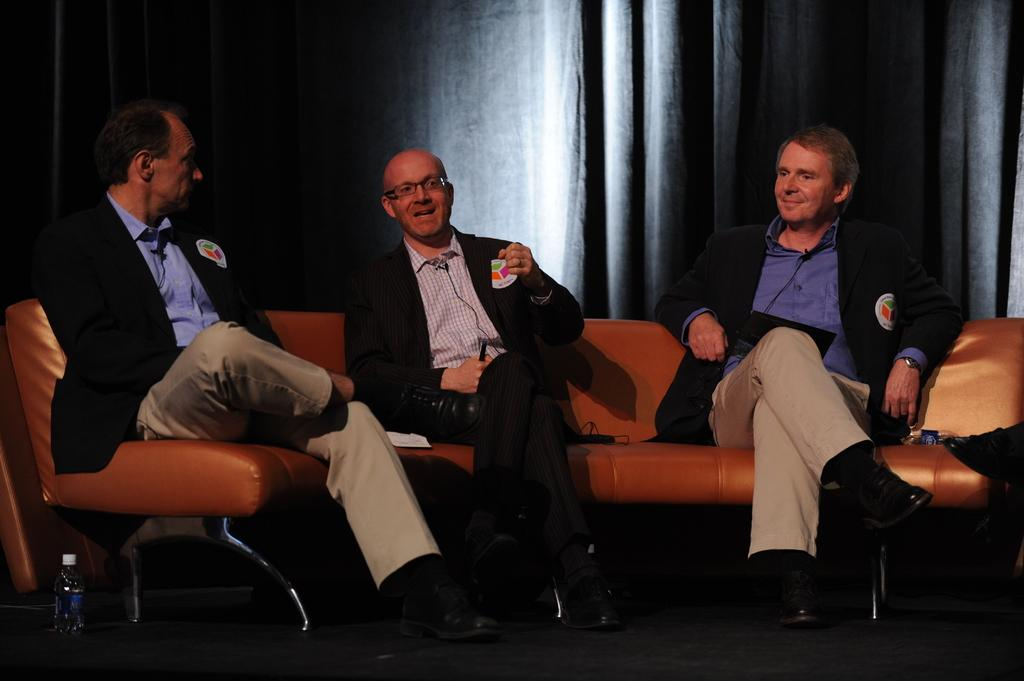How many people are in the image? There are three men in the image. What are the men doing in the image? The men are sitting on a couch. What are the men wearing in the image? The men are wearing suits. What can be seen in the background of the image? There is a black-colored curtain in the background. What object is on the left side of the image? There is a water bottle on the left side of the image. What type of eye is visible on the men's suits in the image? There are no eyes visible on the men's suits in the image. What afterthought might the men have had before sitting on the couch? The image does not provide any information about the men's thoughts or afterthoughts. Is there a locket hanging from the black curtain in the background? There is no locket visible in the image, only a black-colored curtain. 